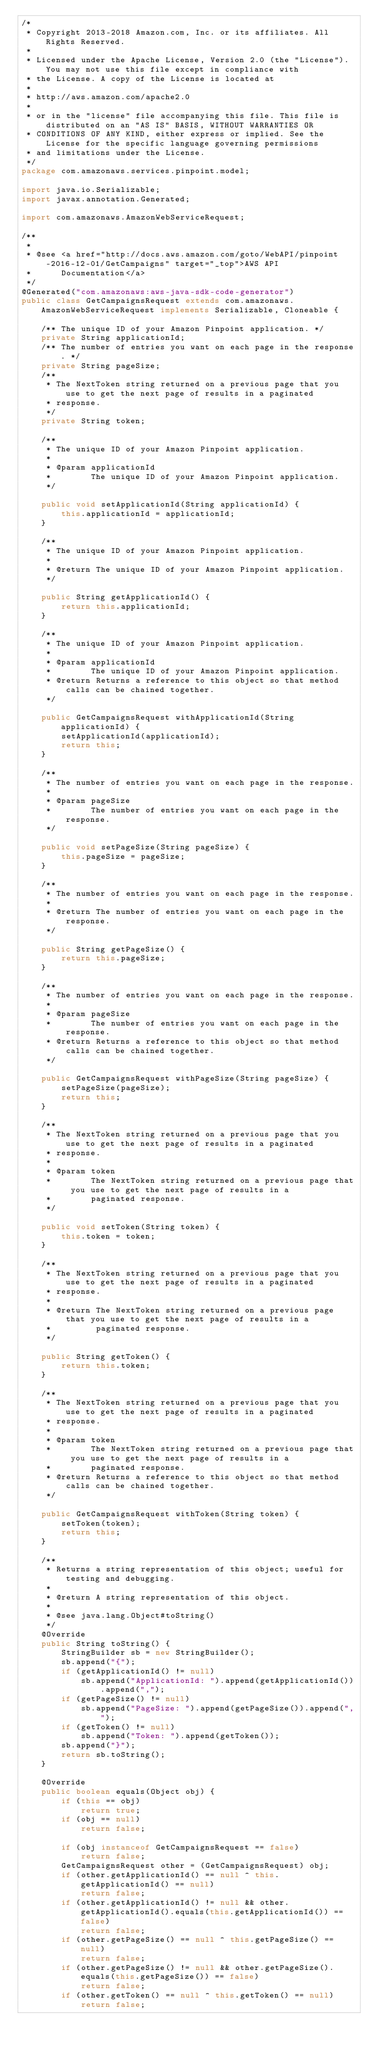Convert code to text. <code><loc_0><loc_0><loc_500><loc_500><_Java_>/*
 * Copyright 2013-2018 Amazon.com, Inc. or its affiliates. All Rights Reserved.
 * 
 * Licensed under the Apache License, Version 2.0 (the "License"). You may not use this file except in compliance with
 * the License. A copy of the License is located at
 * 
 * http://aws.amazon.com/apache2.0
 * 
 * or in the "license" file accompanying this file. This file is distributed on an "AS IS" BASIS, WITHOUT WARRANTIES OR
 * CONDITIONS OF ANY KIND, either express or implied. See the License for the specific language governing permissions
 * and limitations under the License.
 */
package com.amazonaws.services.pinpoint.model;

import java.io.Serializable;
import javax.annotation.Generated;

import com.amazonaws.AmazonWebServiceRequest;

/**
 * 
 * @see <a href="http://docs.aws.amazon.com/goto/WebAPI/pinpoint-2016-12-01/GetCampaigns" target="_top">AWS API
 *      Documentation</a>
 */
@Generated("com.amazonaws:aws-java-sdk-code-generator")
public class GetCampaignsRequest extends com.amazonaws.AmazonWebServiceRequest implements Serializable, Cloneable {

    /** The unique ID of your Amazon Pinpoint application. */
    private String applicationId;
    /** The number of entries you want on each page in the response. */
    private String pageSize;
    /**
     * The NextToken string returned on a previous page that you use to get the next page of results in a paginated
     * response.
     */
    private String token;

    /**
     * The unique ID of your Amazon Pinpoint application.
     * 
     * @param applicationId
     *        The unique ID of your Amazon Pinpoint application.
     */

    public void setApplicationId(String applicationId) {
        this.applicationId = applicationId;
    }

    /**
     * The unique ID of your Amazon Pinpoint application.
     * 
     * @return The unique ID of your Amazon Pinpoint application.
     */

    public String getApplicationId() {
        return this.applicationId;
    }

    /**
     * The unique ID of your Amazon Pinpoint application.
     * 
     * @param applicationId
     *        The unique ID of your Amazon Pinpoint application.
     * @return Returns a reference to this object so that method calls can be chained together.
     */

    public GetCampaignsRequest withApplicationId(String applicationId) {
        setApplicationId(applicationId);
        return this;
    }

    /**
     * The number of entries you want on each page in the response.
     * 
     * @param pageSize
     *        The number of entries you want on each page in the response.
     */

    public void setPageSize(String pageSize) {
        this.pageSize = pageSize;
    }

    /**
     * The number of entries you want on each page in the response.
     * 
     * @return The number of entries you want on each page in the response.
     */

    public String getPageSize() {
        return this.pageSize;
    }

    /**
     * The number of entries you want on each page in the response.
     * 
     * @param pageSize
     *        The number of entries you want on each page in the response.
     * @return Returns a reference to this object so that method calls can be chained together.
     */

    public GetCampaignsRequest withPageSize(String pageSize) {
        setPageSize(pageSize);
        return this;
    }

    /**
     * The NextToken string returned on a previous page that you use to get the next page of results in a paginated
     * response.
     * 
     * @param token
     *        The NextToken string returned on a previous page that you use to get the next page of results in a
     *        paginated response.
     */

    public void setToken(String token) {
        this.token = token;
    }

    /**
     * The NextToken string returned on a previous page that you use to get the next page of results in a paginated
     * response.
     * 
     * @return The NextToken string returned on a previous page that you use to get the next page of results in a
     *         paginated response.
     */

    public String getToken() {
        return this.token;
    }

    /**
     * The NextToken string returned on a previous page that you use to get the next page of results in a paginated
     * response.
     * 
     * @param token
     *        The NextToken string returned on a previous page that you use to get the next page of results in a
     *        paginated response.
     * @return Returns a reference to this object so that method calls can be chained together.
     */

    public GetCampaignsRequest withToken(String token) {
        setToken(token);
        return this;
    }

    /**
     * Returns a string representation of this object; useful for testing and debugging.
     *
     * @return A string representation of this object.
     *
     * @see java.lang.Object#toString()
     */
    @Override
    public String toString() {
        StringBuilder sb = new StringBuilder();
        sb.append("{");
        if (getApplicationId() != null)
            sb.append("ApplicationId: ").append(getApplicationId()).append(",");
        if (getPageSize() != null)
            sb.append("PageSize: ").append(getPageSize()).append(",");
        if (getToken() != null)
            sb.append("Token: ").append(getToken());
        sb.append("}");
        return sb.toString();
    }

    @Override
    public boolean equals(Object obj) {
        if (this == obj)
            return true;
        if (obj == null)
            return false;

        if (obj instanceof GetCampaignsRequest == false)
            return false;
        GetCampaignsRequest other = (GetCampaignsRequest) obj;
        if (other.getApplicationId() == null ^ this.getApplicationId() == null)
            return false;
        if (other.getApplicationId() != null && other.getApplicationId().equals(this.getApplicationId()) == false)
            return false;
        if (other.getPageSize() == null ^ this.getPageSize() == null)
            return false;
        if (other.getPageSize() != null && other.getPageSize().equals(this.getPageSize()) == false)
            return false;
        if (other.getToken() == null ^ this.getToken() == null)
            return false;</code> 